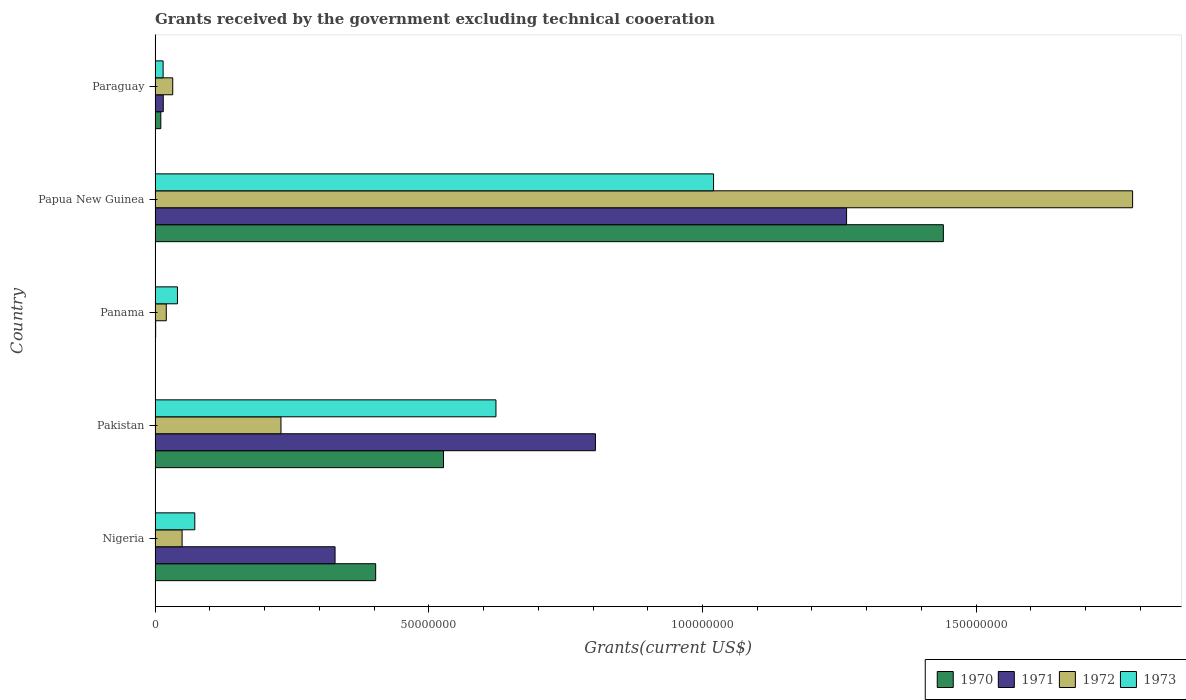How many different coloured bars are there?
Provide a short and direct response. 4. Are the number of bars per tick equal to the number of legend labels?
Provide a succinct answer. No. How many bars are there on the 3rd tick from the top?
Make the answer very short. 3. How many bars are there on the 1st tick from the bottom?
Your answer should be very brief. 4. What is the label of the 3rd group of bars from the top?
Your answer should be compact. Panama. In how many cases, is the number of bars for a given country not equal to the number of legend labels?
Make the answer very short. 1. What is the total grants received by the government in 1973 in Paraguay?
Provide a succinct answer. 1.47e+06. Across all countries, what is the maximum total grants received by the government in 1971?
Ensure brevity in your answer.  1.26e+08. Across all countries, what is the minimum total grants received by the government in 1973?
Ensure brevity in your answer.  1.47e+06. In which country was the total grants received by the government in 1972 maximum?
Keep it short and to the point. Papua New Guinea. What is the total total grants received by the government in 1973 in the graph?
Provide a short and direct response. 1.77e+08. What is the difference between the total grants received by the government in 1971 in Pakistan and that in Papua New Guinea?
Your answer should be very brief. -4.59e+07. What is the difference between the total grants received by the government in 1972 in Panama and the total grants received by the government in 1970 in Pakistan?
Your response must be concise. -5.06e+07. What is the average total grants received by the government in 1973 per country?
Provide a short and direct response. 3.54e+07. What is the difference between the total grants received by the government in 1973 and total grants received by the government in 1971 in Pakistan?
Offer a terse response. -1.82e+07. In how many countries, is the total grants received by the government in 1970 greater than 160000000 US$?
Your answer should be very brief. 0. What is the ratio of the total grants received by the government in 1972 in Panama to that in Paraguay?
Your response must be concise. 0.63. Is the difference between the total grants received by the government in 1973 in Panama and Paraguay greater than the difference between the total grants received by the government in 1971 in Panama and Paraguay?
Your answer should be very brief. Yes. What is the difference between the highest and the second highest total grants received by the government in 1972?
Your answer should be compact. 1.56e+08. What is the difference between the highest and the lowest total grants received by the government in 1972?
Give a very brief answer. 1.77e+08. Is the sum of the total grants received by the government in 1973 in Nigeria and Paraguay greater than the maximum total grants received by the government in 1970 across all countries?
Provide a succinct answer. No. Is it the case that in every country, the sum of the total grants received by the government in 1970 and total grants received by the government in 1972 is greater than the sum of total grants received by the government in 1971 and total grants received by the government in 1973?
Your response must be concise. Yes. Is it the case that in every country, the sum of the total grants received by the government in 1970 and total grants received by the government in 1973 is greater than the total grants received by the government in 1971?
Ensure brevity in your answer.  Yes. Does the graph contain grids?
Give a very brief answer. No. How are the legend labels stacked?
Your answer should be very brief. Horizontal. What is the title of the graph?
Make the answer very short. Grants received by the government excluding technical cooeration. Does "1972" appear as one of the legend labels in the graph?
Keep it short and to the point. Yes. What is the label or title of the X-axis?
Your answer should be compact. Grants(current US$). What is the label or title of the Y-axis?
Your response must be concise. Country. What is the Grants(current US$) in 1970 in Nigeria?
Make the answer very short. 4.03e+07. What is the Grants(current US$) in 1971 in Nigeria?
Offer a terse response. 3.29e+07. What is the Grants(current US$) in 1972 in Nigeria?
Offer a terse response. 4.94e+06. What is the Grants(current US$) in 1973 in Nigeria?
Offer a very short reply. 7.26e+06. What is the Grants(current US$) of 1970 in Pakistan?
Your response must be concise. 5.27e+07. What is the Grants(current US$) in 1971 in Pakistan?
Keep it short and to the point. 8.04e+07. What is the Grants(current US$) of 1972 in Pakistan?
Ensure brevity in your answer.  2.30e+07. What is the Grants(current US$) of 1973 in Pakistan?
Provide a succinct answer. 6.23e+07. What is the Grants(current US$) of 1970 in Panama?
Keep it short and to the point. 0. What is the Grants(current US$) in 1971 in Panama?
Your response must be concise. 1.10e+05. What is the Grants(current US$) in 1972 in Panama?
Provide a succinct answer. 2.05e+06. What is the Grants(current US$) in 1973 in Panama?
Ensure brevity in your answer.  4.09e+06. What is the Grants(current US$) in 1970 in Papua New Guinea?
Your answer should be compact. 1.44e+08. What is the Grants(current US$) of 1971 in Papua New Guinea?
Provide a succinct answer. 1.26e+08. What is the Grants(current US$) in 1972 in Papua New Guinea?
Offer a terse response. 1.79e+08. What is the Grants(current US$) in 1973 in Papua New Guinea?
Your answer should be compact. 1.02e+08. What is the Grants(current US$) in 1970 in Paraguay?
Keep it short and to the point. 1.05e+06. What is the Grants(current US$) of 1971 in Paraguay?
Provide a short and direct response. 1.50e+06. What is the Grants(current US$) of 1972 in Paraguay?
Provide a succinct answer. 3.23e+06. What is the Grants(current US$) of 1973 in Paraguay?
Ensure brevity in your answer.  1.47e+06. Across all countries, what is the maximum Grants(current US$) in 1970?
Provide a short and direct response. 1.44e+08. Across all countries, what is the maximum Grants(current US$) in 1971?
Your answer should be very brief. 1.26e+08. Across all countries, what is the maximum Grants(current US$) of 1972?
Your response must be concise. 1.79e+08. Across all countries, what is the maximum Grants(current US$) in 1973?
Give a very brief answer. 1.02e+08. Across all countries, what is the minimum Grants(current US$) of 1970?
Offer a very short reply. 0. Across all countries, what is the minimum Grants(current US$) in 1971?
Make the answer very short. 1.10e+05. Across all countries, what is the minimum Grants(current US$) of 1972?
Give a very brief answer. 2.05e+06. Across all countries, what is the minimum Grants(current US$) in 1973?
Provide a succinct answer. 1.47e+06. What is the total Grants(current US$) of 1970 in the graph?
Keep it short and to the point. 2.38e+08. What is the total Grants(current US$) in 1971 in the graph?
Provide a succinct answer. 2.41e+08. What is the total Grants(current US$) of 1972 in the graph?
Give a very brief answer. 2.12e+08. What is the total Grants(current US$) in 1973 in the graph?
Your response must be concise. 1.77e+08. What is the difference between the Grants(current US$) of 1970 in Nigeria and that in Pakistan?
Provide a succinct answer. -1.24e+07. What is the difference between the Grants(current US$) of 1971 in Nigeria and that in Pakistan?
Offer a very short reply. -4.76e+07. What is the difference between the Grants(current US$) of 1972 in Nigeria and that in Pakistan?
Offer a very short reply. -1.81e+07. What is the difference between the Grants(current US$) in 1973 in Nigeria and that in Pakistan?
Offer a very short reply. -5.50e+07. What is the difference between the Grants(current US$) of 1971 in Nigeria and that in Panama?
Your answer should be compact. 3.28e+07. What is the difference between the Grants(current US$) in 1972 in Nigeria and that in Panama?
Give a very brief answer. 2.89e+06. What is the difference between the Grants(current US$) of 1973 in Nigeria and that in Panama?
Ensure brevity in your answer.  3.17e+06. What is the difference between the Grants(current US$) in 1970 in Nigeria and that in Papua New Guinea?
Provide a succinct answer. -1.04e+08. What is the difference between the Grants(current US$) of 1971 in Nigeria and that in Papua New Guinea?
Offer a very short reply. -9.34e+07. What is the difference between the Grants(current US$) of 1972 in Nigeria and that in Papua New Guinea?
Keep it short and to the point. -1.74e+08. What is the difference between the Grants(current US$) of 1973 in Nigeria and that in Papua New Guinea?
Provide a succinct answer. -9.48e+07. What is the difference between the Grants(current US$) of 1970 in Nigeria and that in Paraguay?
Provide a succinct answer. 3.92e+07. What is the difference between the Grants(current US$) of 1971 in Nigeria and that in Paraguay?
Offer a terse response. 3.14e+07. What is the difference between the Grants(current US$) in 1972 in Nigeria and that in Paraguay?
Provide a short and direct response. 1.71e+06. What is the difference between the Grants(current US$) in 1973 in Nigeria and that in Paraguay?
Your answer should be compact. 5.79e+06. What is the difference between the Grants(current US$) in 1971 in Pakistan and that in Panama?
Ensure brevity in your answer.  8.03e+07. What is the difference between the Grants(current US$) in 1972 in Pakistan and that in Panama?
Your answer should be compact. 2.10e+07. What is the difference between the Grants(current US$) in 1973 in Pakistan and that in Panama?
Your answer should be compact. 5.82e+07. What is the difference between the Grants(current US$) in 1970 in Pakistan and that in Papua New Guinea?
Your answer should be compact. -9.13e+07. What is the difference between the Grants(current US$) in 1971 in Pakistan and that in Papua New Guinea?
Your answer should be compact. -4.59e+07. What is the difference between the Grants(current US$) in 1972 in Pakistan and that in Papua New Guinea?
Your answer should be very brief. -1.56e+08. What is the difference between the Grants(current US$) of 1973 in Pakistan and that in Papua New Guinea?
Keep it short and to the point. -3.98e+07. What is the difference between the Grants(current US$) of 1970 in Pakistan and that in Paraguay?
Your response must be concise. 5.16e+07. What is the difference between the Grants(current US$) in 1971 in Pakistan and that in Paraguay?
Keep it short and to the point. 7.89e+07. What is the difference between the Grants(current US$) of 1972 in Pakistan and that in Paraguay?
Ensure brevity in your answer.  1.98e+07. What is the difference between the Grants(current US$) of 1973 in Pakistan and that in Paraguay?
Your answer should be very brief. 6.08e+07. What is the difference between the Grants(current US$) in 1971 in Panama and that in Papua New Guinea?
Offer a terse response. -1.26e+08. What is the difference between the Grants(current US$) of 1972 in Panama and that in Papua New Guinea?
Your answer should be compact. -1.77e+08. What is the difference between the Grants(current US$) in 1973 in Panama and that in Papua New Guinea?
Make the answer very short. -9.79e+07. What is the difference between the Grants(current US$) of 1971 in Panama and that in Paraguay?
Your answer should be very brief. -1.39e+06. What is the difference between the Grants(current US$) in 1972 in Panama and that in Paraguay?
Keep it short and to the point. -1.18e+06. What is the difference between the Grants(current US$) in 1973 in Panama and that in Paraguay?
Give a very brief answer. 2.62e+06. What is the difference between the Grants(current US$) of 1970 in Papua New Guinea and that in Paraguay?
Give a very brief answer. 1.43e+08. What is the difference between the Grants(current US$) of 1971 in Papua New Guinea and that in Paraguay?
Your answer should be compact. 1.25e+08. What is the difference between the Grants(current US$) of 1972 in Papua New Guinea and that in Paraguay?
Offer a terse response. 1.75e+08. What is the difference between the Grants(current US$) in 1973 in Papua New Guinea and that in Paraguay?
Offer a very short reply. 1.01e+08. What is the difference between the Grants(current US$) in 1970 in Nigeria and the Grants(current US$) in 1971 in Pakistan?
Provide a succinct answer. -4.01e+07. What is the difference between the Grants(current US$) of 1970 in Nigeria and the Grants(current US$) of 1972 in Pakistan?
Your answer should be compact. 1.73e+07. What is the difference between the Grants(current US$) of 1970 in Nigeria and the Grants(current US$) of 1973 in Pakistan?
Keep it short and to the point. -2.20e+07. What is the difference between the Grants(current US$) in 1971 in Nigeria and the Grants(current US$) in 1972 in Pakistan?
Your response must be concise. 9.88e+06. What is the difference between the Grants(current US$) in 1971 in Nigeria and the Grants(current US$) in 1973 in Pakistan?
Offer a terse response. -2.94e+07. What is the difference between the Grants(current US$) in 1972 in Nigeria and the Grants(current US$) in 1973 in Pakistan?
Your response must be concise. -5.73e+07. What is the difference between the Grants(current US$) of 1970 in Nigeria and the Grants(current US$) of 1971 in Panama?
Your answer should be very brief. 4.02e+07. What is the difference between the Grants(current US$) in 1970 in Nigeria and the Grants(current US$) in 1972 in Panama?
Provide a short and direct response. 3.82e+07. What is the difference between the Grants(current US$) of 1970 in Nigeria and the Grants(current US$) of 1973 in Panama?
Your answer should be very brief. 3.62e+07. What is the difference between the Grants(current US$) in 1971 in Nigeria and the Grants(current US$) in 1972 in Panama?
Keep it short and to the point. 3.08e+07. What is the difference between the Grants(current US$) of 1971 in Nigeria and the Grants(current US$) of 1973 in Panama?
Ensure brevity in your answer.  2.88e+07. What is the difference between the Grants(current US$) in 1972 in Nigeria and the Grants(current US$) in 1973 in Panama?
Keep it short and to the point. 8.50e+05. What is the difference between the Grants(current US$) of 1970 in Nigeria and the Grants(current US$) of 1971 in Papua New Guinea?
Make the answer very short. -8.60e+07. What is the difference between the Grants(current US$) in 1970 in Nigeria and the Grants(current US$) in 1972 in Papua New Guinea?
Provide a short and direct response. -1.38e+08. What is the difference between the Grants(current US$) of 1970 in Nigeria and the Grants(current US$) of 1973 in Papua New Guinea?
Provide a short and direct response. -6.17e+07. What is the difference between the Grants(current US$) of 1971 in Nigeria and the Grants(current US$) of 1972 in Papua New Guinea?
Your answer should be very brief. -1.46e+08. What is the difference between the Grants(current US$) of 1971 in Nigeria and the Grants(current US$) of 1973 in Papua New Guinea?
Your answer should be very brief. -6.91e+07. What is the difference between the Grants(current US$) of 1972 in Nigeria and the Grants(current US$) of 1973 in Papua New Guinea?
Provide a short and direct response. -9.71e+07. What is the difference between the Grants(current US$) of 1970 in Nigeria and the Grants(current US$) of 1971 in Paraguay?
Make the answer very short. 3.88e+07. What is the difference between the Grants(current US$) in 1970 in Nigeria and the Grants(current US$) in 1972 in Paraguay?
Give a very brief answer. 3.71e+07. What is the difference between the Grants(current US$) in 1970 in Nigeria and the Grants(current US$) in 1973 in Paraguay?
Your response must be concise. 3.88e+07. What is the difference between the Grants(current US$) of 1971 in Nigeria and the Grants(current US$) of 1972 in Paraguay?
Your response must be concise. 2.96e+07. What is the difference between the Grants(current US$) of 1971 in Nigeria and the Grants(current US$) of 1973 in Paraguay?
Offer a terse response. 3.14e+07. What is the difference between the Grants(current US$) of 1972 in Nigeria and the Grants(current US$) of 1973 in Paraguay?
Give a very brief answer. 3.47e+06. What is the difference between the Grants(current US$) in 1970 in Pakistan and the Grants(current US$) in 1971 in Panama?
Your response must be concise. 5.26e+07. What is the difference between the Grants(current US$) in 1970 in Pakistan and the Grants(current US$) in 1972 in Panama?
Give a very brief answer. 5.06e+07. What is the difference between the Grants(current US$) of 1970 in Pakistan and the Grants(current US$) of 1973 in Panama?
Give a very brief answer. 4.86e+07. What is the difference between the Grants(current US$) of 1971 in Pakistan and the Grants(current US$) of 1972 in Panama?
Ensure brevity in your answer.  7.84e+07. What is the difference between the Grants(current US$) in 1971 in Pakistan and the Grants(current US$) in 1973 in Panama?
Give a very brief answer. 7.64e+07. What is the difference between the Grants(current US$) of 1972 in Pakistan and the Grants(current US$) of 1973 in Panama?
Your response must be concise. 1.89e+07. What is the difference between the Grants(current US$) in 1970 in Pakistan and the Grants(current US$) in 1971 in Papua New Guinea?
Ensure brevity in your answer.  -7.36e+07. What is the difference between the Grants(current US$) in 1970 in Pakistan and the Grants(current US$) in 1972 in Papua New Guinea?
Your response must be concise. -1.26e+08. What is the difference between the Grants(current US$) of 1970 in Pakistan and the Grants(current US$) of 1973 in Papua New Guinea?
Keep it short and to the point. -4.93e+07. What is the difference between the Grants(current US$) in 1971 in Pakistan and the Grants(current US$) in 1972 in Papua New Guinea?
Make the answer very short. -9.81e+07. What is the difference between the Grants(current US$) of 1971 in Pakistan and the Grants(current US$) of 1973 in Papua New Guinea?
Your answer should be compact. -2.16e+07. What is the difference between the Grants(current US$) in 1972 in Pakistan and the Grants(current US$) in 1973 in Papua New Guinea?
Your response must be concise. -7.90e+07. What is the difference between the Grants(current US$) of 1970 in Pakistan and the Grants(current US$) of 1971 in Paraguay?
Your answer should be very brief. 5.12e+07. What is the difference between the Grants(current US$) of 1970 in Pakistan and the Grants(current US$) of 1972 in Paraguay?
Your answer should be very brief. 4.95e+07. What is the difference between the Grants(current US$) in 1970 in Pakistan and the Grants(current US$) in 1973 in Paraguay?
Ensure brevity in your answer.  5.12e+07. What is the difference between the Grants(current US$) in 1971 in Pakistan and the Grants(current US$) in 1972 in Paraguay?
Your answer should be very brief. 7.72e+07. What is the difference between the Grants(current US$) in 1971 in Pakistan and the Grants(current US$) in 1973 in Paraguay?
Your answer should be very brief. 7.90e+07. What is the difference between the Grants(current US$) in 1972 in Pakistan and the Grants(current US$) in 1973 in Paraguay?
Make the answer very short. 2.15e+07. What is the difference between the Grants(current US$) of 1971 in Panama and the Grants(current US$) of 1972 in Papua New Guinea?
Offer a very short reply. -1.78e+08. What is the difference between the Grants(current US$) in 1971 in Panama and the Grants(current US$) in 1973 in Papua New Guinea?
Offer a very short reply. -1.02e+08. What is the difference between the Grants(current US$) in 1972 in Panama and the Grants(current US$) in 1973 in Papua New Guinea?
Offer a terse response. -1.00e+08. What is the difference between the Grants(current US$) in 1971 in Panama and the Grants(current US$) in 1972 in Paraguay?
Offer a very short reply. -3.12e+06. What is the difference between the Grants(current US$) in 1971 in Panama and the Grants(current US$) in 1973 in Paraguay?
Give a very brief answer. -1.36e+06. What is the difference between the Grants(current US$) of 1972 in Panama and the Grants(current US$) of 1973 in Paraguay?
Your response must be concise. 5.80e+05. What is the difference between the Grants(current US$) of 1970 in Papua New Guinea and the Grants(current US$) of 1971 in Paraguay?
Give a very brief answer. 1.42e+08. What is the difference between the Grants(current US$) of 1970 in Papua New Guinea and the Grants(current US$) of 1972 in Paraguay?
Your response must be concise. 1.41e+08. What is the difference between the Grants(current US$) in 1970 in Papua New Guinea and the Grants(current US$) in 1973 in Paraguay?
Your answer should be compact. 1.43e+08. What is the difference between the Grants(current US$) of 1971 in Papua New Guinea and the Grants(current US$) of 1972 in Paraguay?
Provide a succinct answer. 1.23e+08. What is the difference between the Grants(current US$) in 1971 in Papua New Guinea and the Grants(current US$) in 1973 in Paraguay?
Make the answer very short. 1.25e+08. What is the difference between the Grants(current US$) of 1972 in Papua New Guinea and the Grants(current US$) of 1973 in Paraguay?
Provide a short and direct response. 1.77e+08. What is the average Grants(current US$) in 1970 per country?
Make the answer very short. 4.76e+07. What is the average Grants(current US$) of 1971 per country?
Your answer should be compact. 4.82e+07. What is the average Grants(current US$) in 1972 per country?
Offer a terse response. 4.24e+07. What is the average Grants(current US$) in 1973 per country?
Offer a very short reply. 3.54e+07. What is the difference between the Grants(current US$) of 1970 and Grants(current US$) of 1971 in Nigeria?
Keep it short and to the point. 7.42e+06. What is the difference between the Grants(current US$) in 1970 and Grants(current US$) in 1972 in Nigeria?
Make the answer very short. 3.54e+07. What is the difference between the Grants(current US$) in 1970 and Grants(current US$) in 1973 in Nigeria?
Provide a short and direct response. 3.30e+07. What is the difference between the Grants(current US$) of 1971 and Grants(current US$) of 1972 in Nigeria?
Offer a very short reply. 2.79e+07. What is the difference between the Grants(current US$) in 1971 and Grants(current US$) in 1973 in Nigeria?
Provide a succinct answer. 2.56e+07. What is the difference between the Grants(current US$) in 1972 and Grants(current US$) in 1973 in Nigeria?
Provide a short and direct response. -2.32e+06. What is the difference between the Grants(current US$) in 1970 and Grants(current US$) in 1971 in Pakistan?
Your response must be concise. -2.78e+07. What is the difference between the Grants(current US$) of 1970 and Grants(current US$) of 1972 in Pakistan?
Offer a very short reply. 2.97e+07. What is the difference between the Grants(current US$) of 1970 and Grants(current US$) of 1973 in Pakistan?
Ensure brevity in your answer.  -9.58e+06. What is the difference between the Grants(current US$) of 1971 and Grants(current US$) of 1972 in Pakistan?
Your response must be concise. 5.74e+07. What is the difference between the Grants(current US$) of 1971 and Grants(current US$) of 1973 in Pakistan?
Your answer should be very brief. 1.82e+07. What is the difference between the Grants(current US$) in 1972 and Grants(current US$) in 1973 in Pakistan?
Provide a succinct answer. -3.93e+07. What is the difference between the Grants(current US$) of 1971 and Grants(current US$) of 1972 in Panama?
Provide a short and direct response. -1.94e+06. What is the difference between the Grants(current US$) of 1971 and Grants(current US$) of 1973 in Panama?
Provide a short and direct response. -3.98e+06. What is the difference between the Grants(current US$) in 1972 and Grants(current US$) in 1973 in Panama?
Make the answer very short. -2.04e+06. What is the difference between the Grants(current US$) in 1970 and Grants(current US$) in 1971 in Papua New Guinea?
Give a very brief answer. 1.77e+07. What is the difference between the Grants(current US$) in 1970 and Grants(current US$) in 1972 in Papua New Guinea?
Keep it short and to the point. -3.46e+07. What is the difference between the Grants(current US$) of 1970 and Grants(current US$) of 1973 in Papua New Guinea?
Your answer should be compact. 4.20e+07. What is the difference between the Grants(current US$) of 1971 and Grants(current US$) of 1972 in Papua New Guinea?
Your response must be concise. -5.22e+07. What is the difference between the Grants(current US$) in 1971 and Grants(current US$) in 1973 in Papua New Guinea?
Your response must be concise. 2.43e+07. What is the difference between the Grants(current US$) of 1972 and Grants(current US$) of 1973 in Papua New Guinea?
Provide a short and direct response. 7.66e+07. What is the difference between the Grants(current US$) of 1970 and Grants(current US$) of 1971 in Paraguay?
Your answer should be compact. -4.50e+05. What is the difference between the Grants(current US$) in 1970 and Grants(current US$) in 1972 in Paraguay?
Give a very brief answer. -2.18e+06. What is the difference between the Grants(current US$) of 1970 and Grants(current US$) of 1973 in Paraguay?
Provide a short and direct response. -4.20e+05. What is the difference between the Grants(current US$) of 1971 and Grants(current US$) of 1972 in Paraguay?
Make the answer very short. -1.73e+06. What is the difference between the Grants(current US$) of 1972 and Grants(current US$) of 1973 in Paraguay?
Your answer should be very brief. 1.76e+06. What is the ratio of the Grants(current US$) in 1970 in Nigeria to that in Pakistan?
Offer a very short reply. 0.76. What is the ratio of the Grants(current US$) of 1971 in Nigeria to that in Pakistan?
Ensure brevity in your answer.  0.41. What is the ratio of the Grants(current US$) of 1972 in Nigeria to that in Pakistan?
Provide a short and direct response. 0.21. What is the ratio of the Grants(current US$) in 1973 in Nigeria to that in Pakistan?
Keep it short and to the point. 0.12. What is the ratio of the Grants(current US$) in 1971 in Nigeria to that in Panama?
Make the answer very short. 298.91. What is the ratio of the Grants(current US$) in 1972 in Nigeria to that in Panama?
Offer a terse response. 2.41. What is the ratio of the Grants(current US$) of 1973 in Nigeria to that in Panama?
Your answer should be compact. 1.78. What is the ratio of the Grants(current US$) in 1970 in Nigeria to that in Papua New Guinea?
Provide a succinct answer. 0.28. What is the ratio of the Grants(current US$) of 1971 in Nigeria to that in Papua New Guinea?
Give a very brief answer. 0.26. What is the ratio of the Grants(current US$) of 1972 in Nigeria to that in Papua New Guinea?
Offer a very short reply. 0.03. What is the ratio of the Grants(current US$) of 1973 in Nigeria to that in Papua New Guinea?
Provide a short and direct response. 0.07. What is the ratio of the Grants(current US$) of 1970 in Nigeria to that in Paraguay?
Make the answer very short. 38.38. What is the ratio of the Grants(current US$) in 1971 in Nigeria to that in Paraguay?
Provide a succinct answer. 21.92. What is the ratio of the Grants(current US$) of 1972 in Nigeria to that in Paraguay?
Your answer should be compact. 1.53. What is the ratio of the Grants(current US$) of 1973 in Nigeria to that in Paraguay?
Offer a very short reply. 4.94. What is the ratio of the Grants(current US$) of 1971 in Pakistan to that in Panama?
Keep it short and to the point. 731.27. What is the ratio of the Grants(current US$) of 1972 in Pakistan to that in Panama?
Ensure brevity in your answer.  11.22. What is the ratio of the Grants(current US$) in 1973 in Pakistan to that in Panama?
Ensure brevity in your answer.  15.22. What is the ratio of the Grants(current US$) of 1970 in Pakistan to that in Papua New Guinea?
Give a very brief answer. 0.37. What is the ratio of the Grants(current US$) of 1971 in Pakistan to that in Papua New Guinea?
Ensure brevity in your answer.  0.64. What is the ratio of the Grants(current US$) in 1972 in Pakistan to that in Papua New Guinea?
Offer a terse response. 0.13. What is the ratio of the Grants(current US$) of 1973 in Pakistan to that in Papua New Guinea?
Your response must be concise. 0.61. What is the ratio of the Grants(current US$) in 1970 in Pakistan to that in Paraguay?
Make the answer very short. 50.18. What is the ratio of the Grants(current US$) in 1971 in Pakistan to that in Paraguay?
Offer a very short reply. 53.63. What is the ratio of the Grants(current US$) in 1972 in Pakistan to that in Paraguay?
Offer a terse response. 7.12. What is the ratio of the Grants(current US$) of 1973 in Pakistan to that in Paraguay?
Your response must be concise. 42.36. What is the ratio of the Grants(current US$) in 1971 in Panama to that in Papua New Guinea?
Make the answer very short. 0. What is the ratio of the Grants(current US$) of 1972 in Panama to that in Papua New Guinea?
Provide a short and direct response. 0.01. What is the ratio of the Grants(current US$) in 1973 in Panama to that in Papua New Guinea?
Give a very brief answer. 0.04. What is the ratio of the Grants(current US$) of 1971 in Panama to that in Paraguay?
Provide a short and direct response. 0.07. What is the ratio of the Grants(current US$) in 1972 in Panama to that in Paraguay?
Your answer should be very brief. 0.63. What is the ratio of the Grants(current US$) in 1973 in Panama to that in Paraguay?
Offer a terse response. 2.78. What is the ratio of the Grants(current US$) of 1970 in Papua New Guinea to that in Paraguay?
Your answer should be very brief. 137.14. What is the ratio of the Grants(current US$) in 1971 in Papua New Guinea to that in Paraguay?
Offer a terse response. 84.21. What is the ratio of the Grants(current US$) in 1972 in Papua New Guinea to that in Paraguay?
Give a very brief answer. 55.28. What is the ratio of the Grants(current US$) in 1973 in Papua New Guinea to that in Paraguay?
Provide a short and direct response. 69.4. What is the difference between the highest and the second highest Grants(current US$) in 1970?
Make the answer very short. 9.13e+07. What is the difference between the highest and the second highest Grants(current US$) of 1971?
Offer a terse response. 4.59e+07. What is the difference between the highest and the second highest Grants(current US$) of 1972?
Give a very brief answer. 1.56e+08. What is the difference between the highest and the second highest Grants(current US$) of 1973?
Give a very brief answer. 3.98e+07. What is the difference between the highest and the lowest Grants(current US$) of 1970?
Your answer should be very brief. 1.44e+08. What is the difference between the highest and the lowest Grants(current US$) of 1971?
Your answer should be very brief. 1.26e+08. What is the difference between the highest and the lowest Grants(current US$) in 1972?
Provide a succinct answer. 1.77e+08. What is the difference between the highest and the lowest Grants(current US$) in 1973?
Provide a short and direct response. 1.01e+08. 